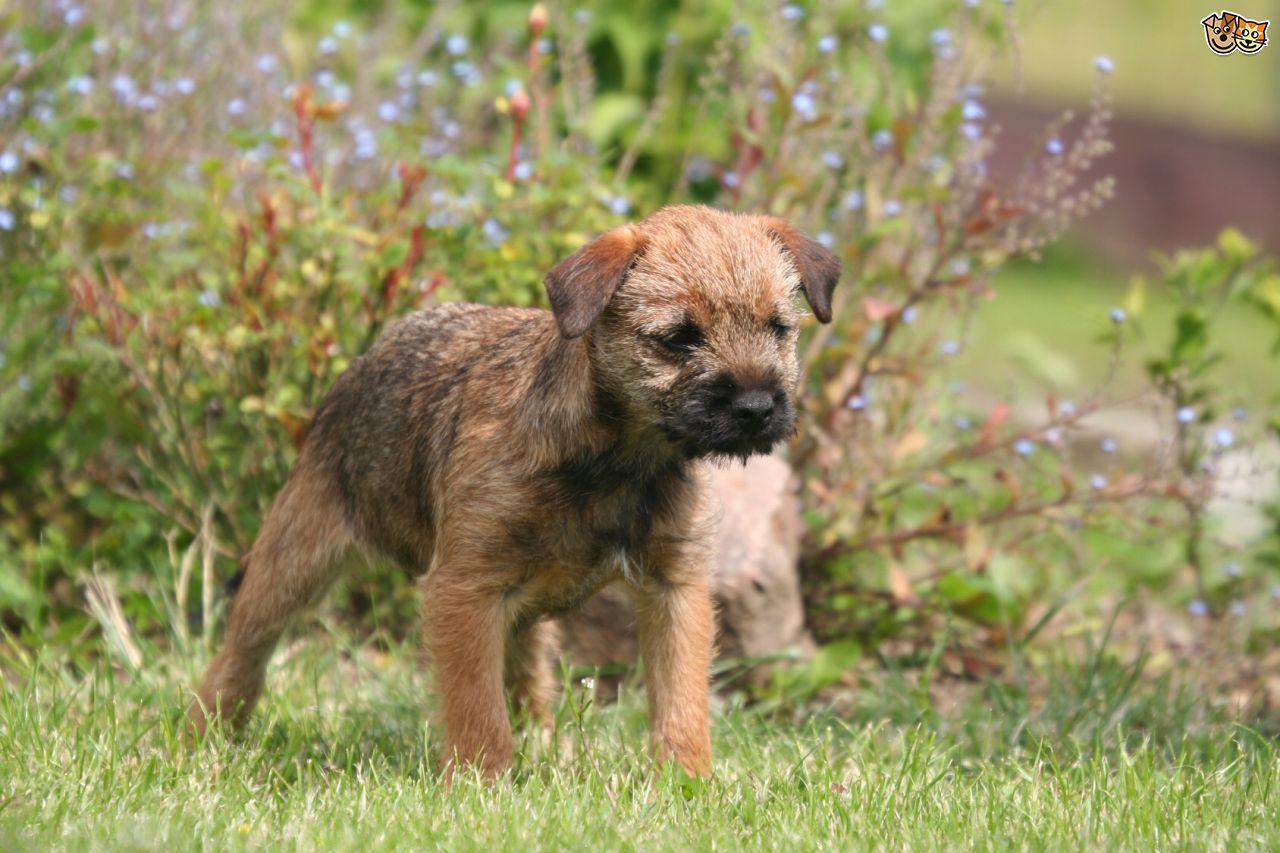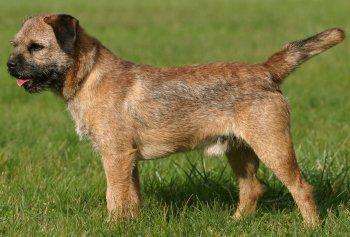The first image is the image on the left, the second image is the image on the right. For the images shown, is this caption "At least one image shows one dog standing on grass in profile with pointing tail." true? Answer yes or no. Yes. 